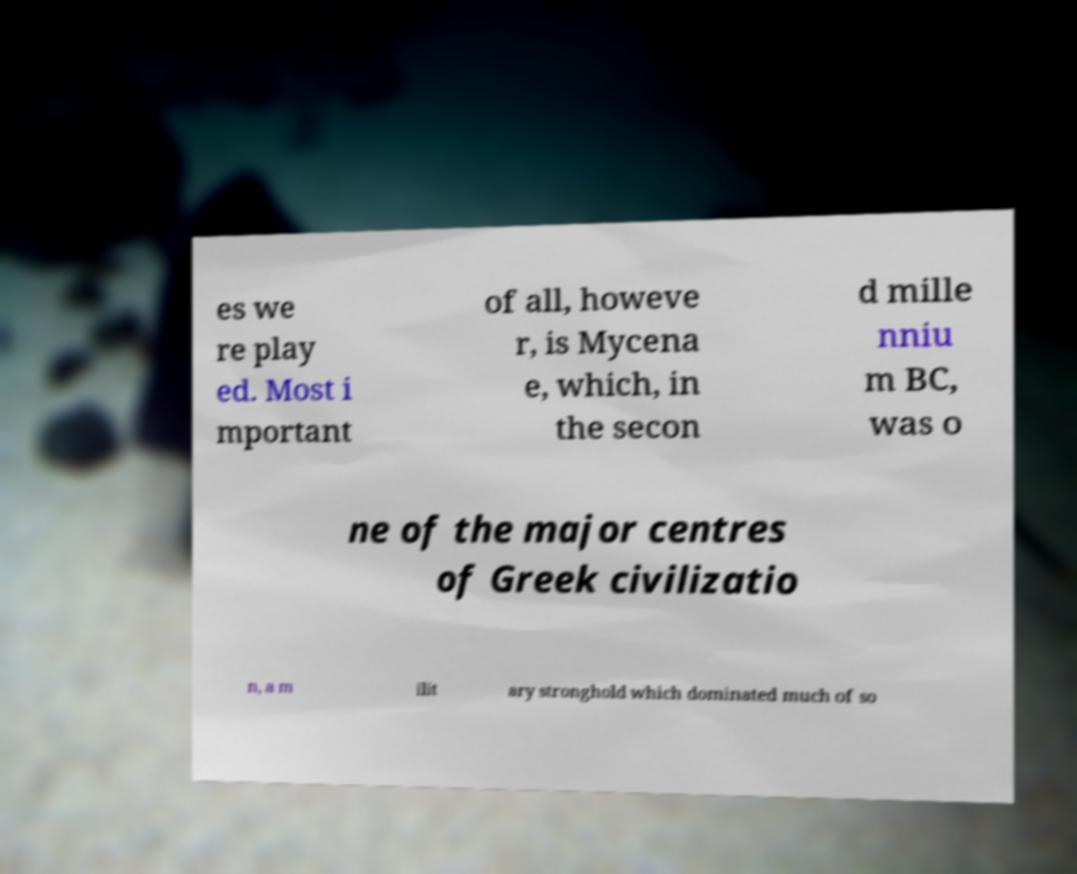I need the written content from this picture converted into text. Can you do that? es we re play ed. Most i mportant of all, howeve r, is Mycena e, which, in the secon d mille nniu m BC, was o ne of the major centres of Greek civilizatio n, a m ilit ary stronghold which dominated much of so 